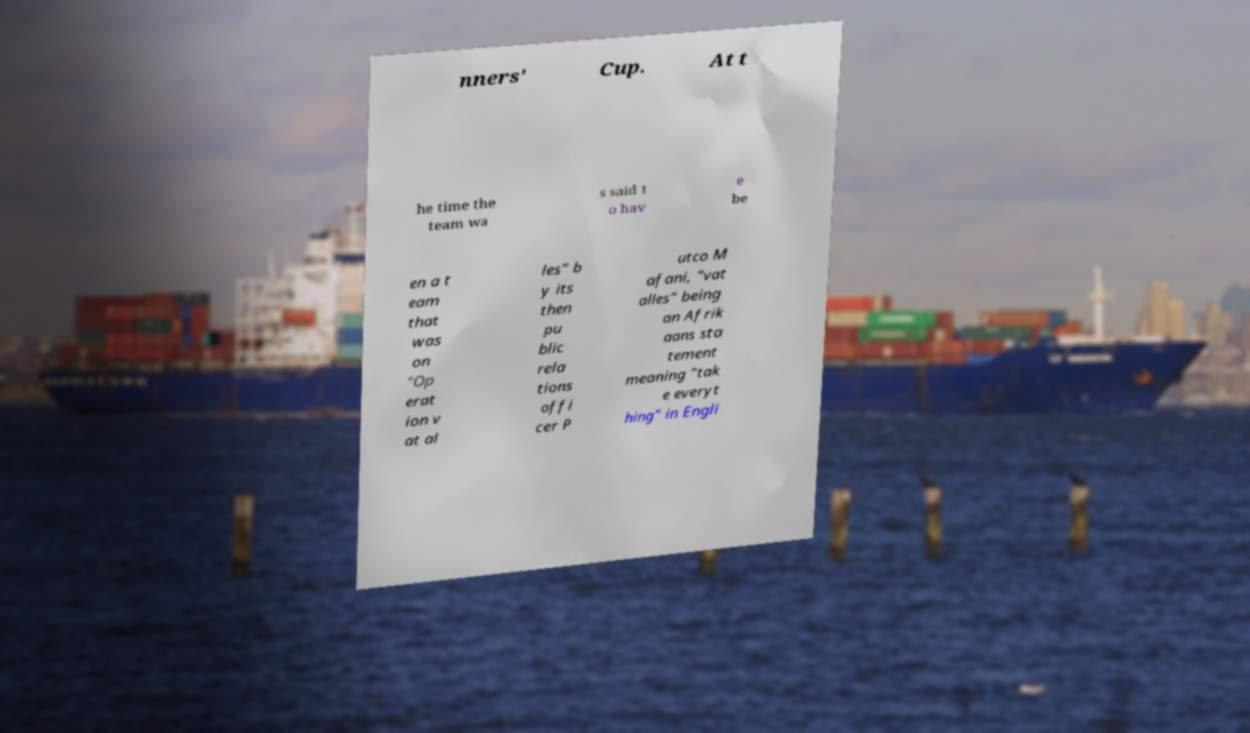Could you assist in decoding the text presented in this image and type it out clearly? nners' Cup. At t he time the team wa s said t o hav e be en a t eam that was on "Op erat ion v at al les" b y its then pu blic rela tions offi cer P utco M afani, "vat alles" being an Afrik aans sta tement meaning "tak e everyt hing" in Engli 